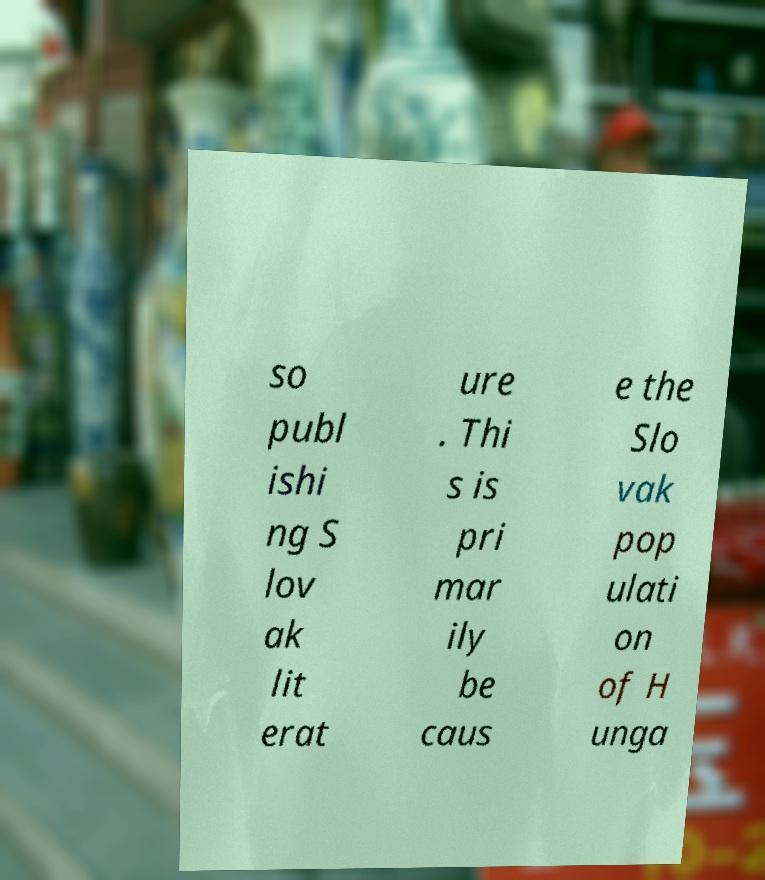Could you assist in decoding the text presented in this image and type it out clearly? so publ ishi ng S lov ak lit erat ure . Thi s is pri mar ily be caus e the Slo vak pop ulati on of H unga 